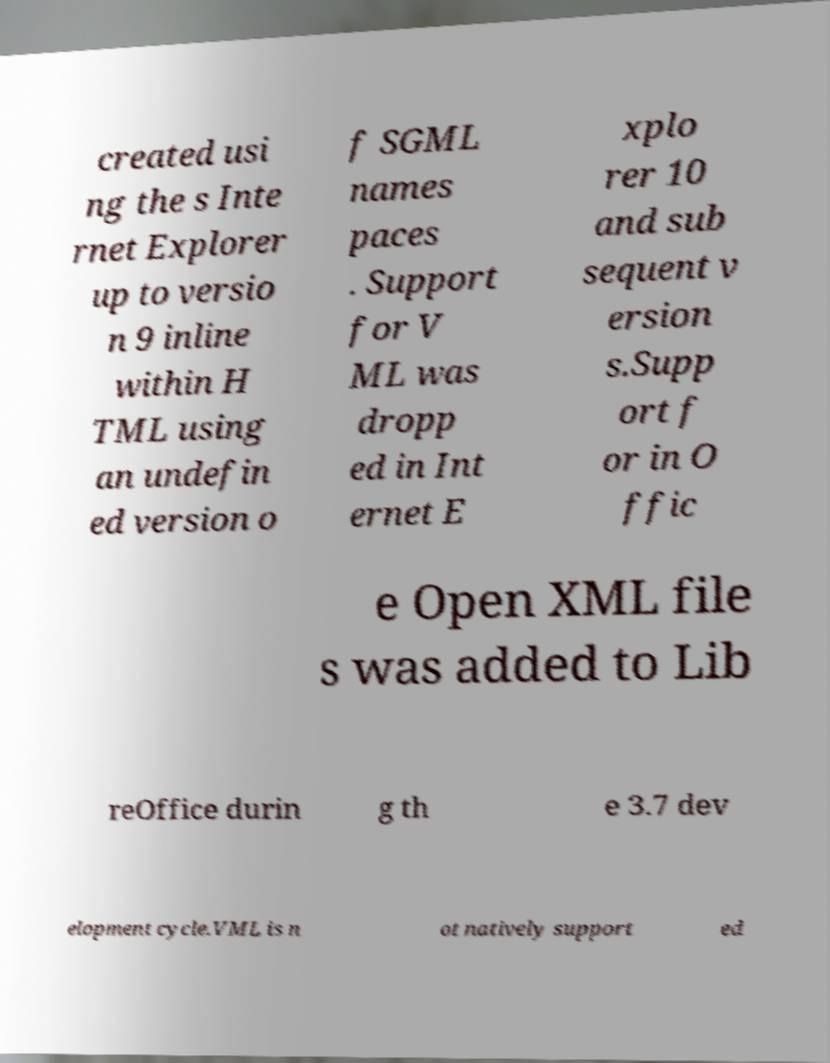There's text embedded in this image that I need extracted. Can you transcribe it verbatim? created usi ng the s Inte rnet Explorer up to versio n 9 inline within H TML using an undefin ed version o f SGML names paces . Support for V ML was dropp ed in Int ernet E xplo rer 10 and sub sequent v ersion s.Supp ort f or in O ffic e Open XML file s was added to Lib reOffice durin g th e 3.7 dev elopment cycle.VML is n ot natively support ed 